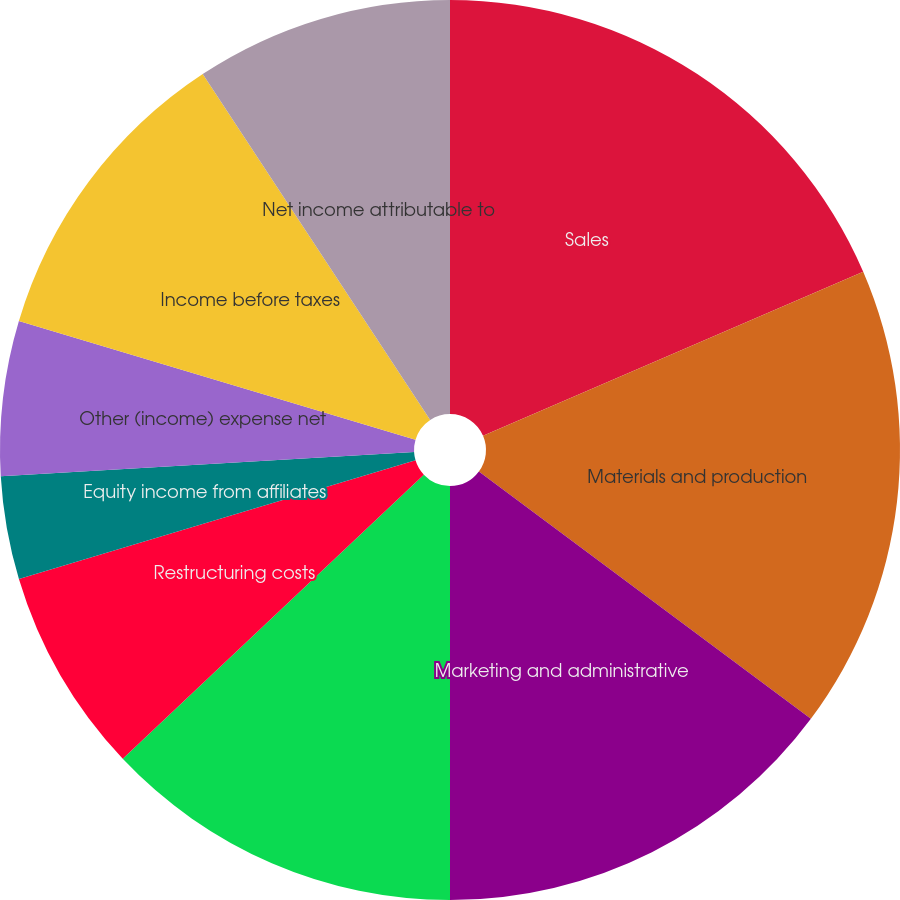<chart> <loc_0><loc_0><loc_500><loc_500><pie_chart><fcel>Sales<fcel>Materials and production<fcel>Marketing and administrative<fcel>Research and development<fcel>Restructuring costs<fcel>Equity income from affiliates<fcel>Other (income) expense net<fcel>Income before taxes<fcel>Net income attributable to<fcel>Basic earnings per common<nl><fcel>18.52%<fcel>16.67%<fcel>14.81%<fcel>12.96%<fcel>7.41%<fcel>3.7%<fcel>5.56%<fcel>11.11%<fcel>9.26%<fcel>0.0%<nl></chart> 